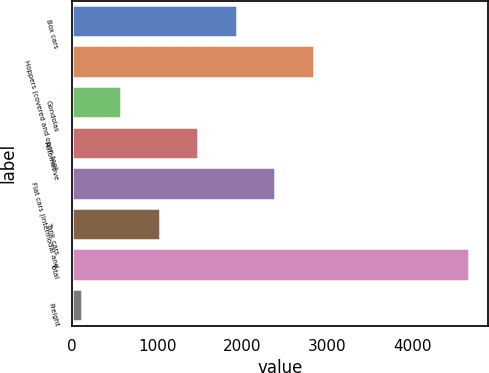Convert chart to OTSL. <chart><loc_0><loc_0><loc_500><loc_500><bar_chart><fcel>Box cars<fcel>Hoppers (covered and open top)<fcel>Gondolas<fcel>Automotive<fcel>Flat cars (intermodal and<fcel>Tank cars<fcel>Total<fcel>Freight<nl><fcel>1933.4<fcel>2840.6<fcel>572.6<fcel>1479.8<fcel>2387<fcel>1026.2<fcel>4655<fcel>119<nl></chart> 